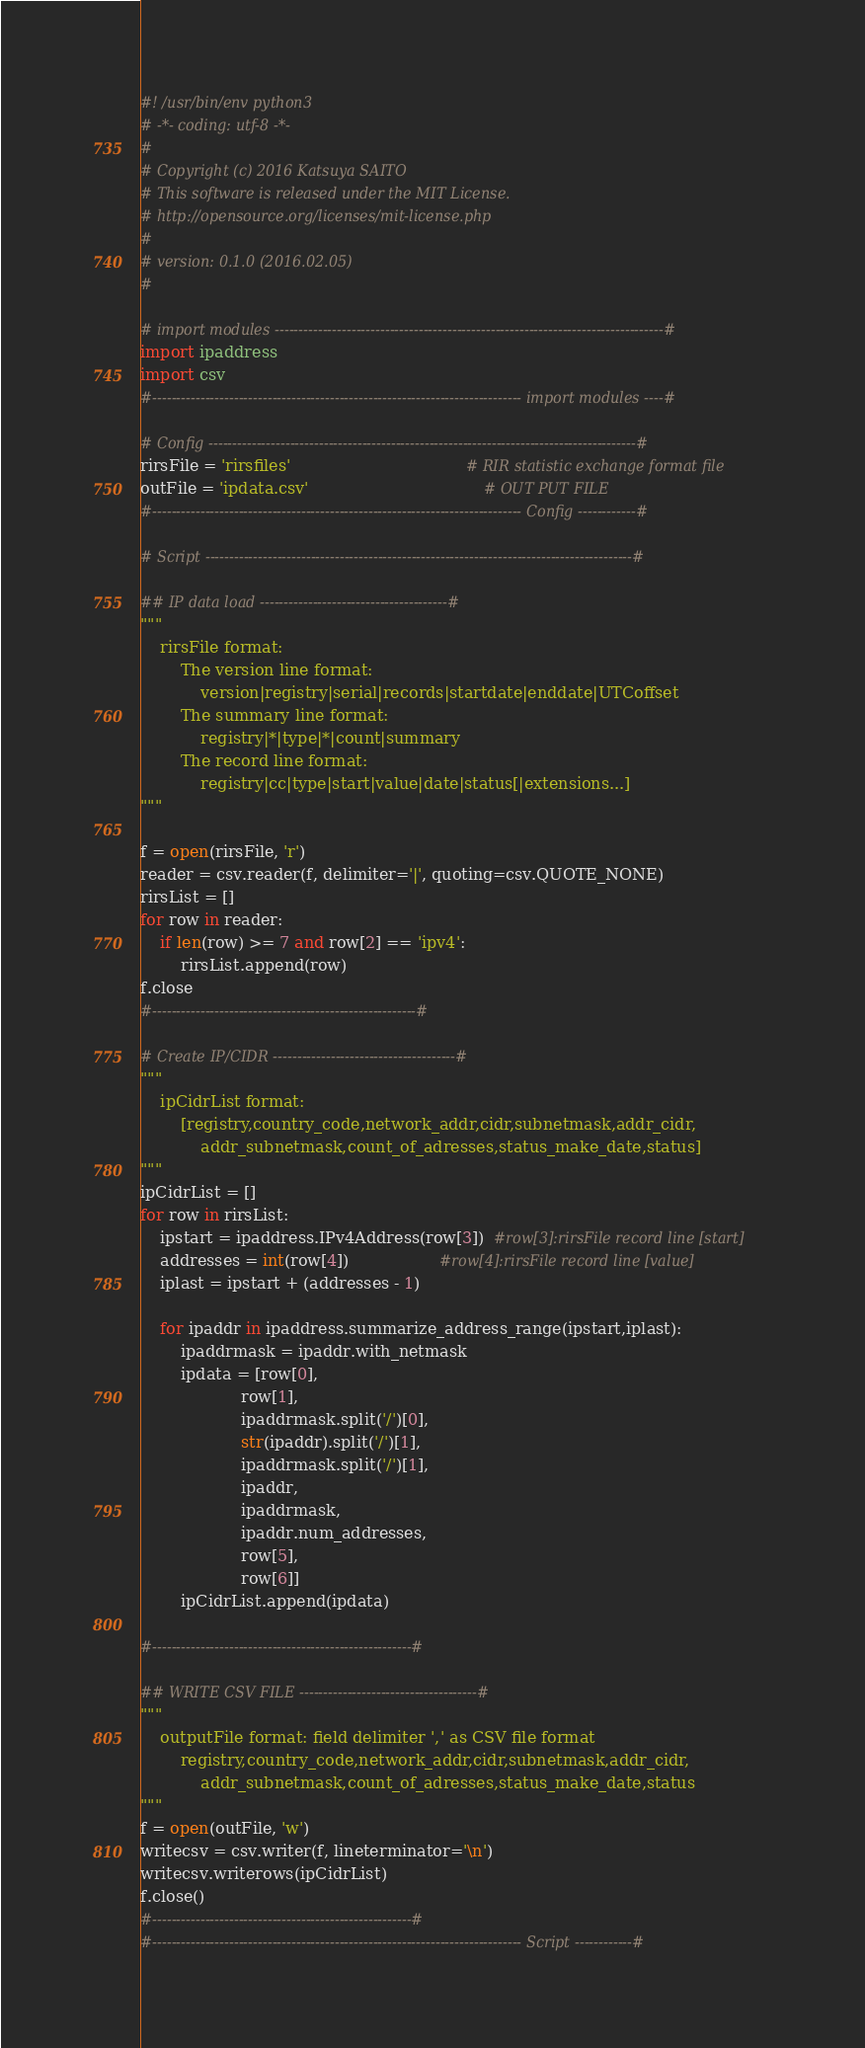<code> <loc_0><loc_0><loc_500><loc_500><_Python_>#! /usr/bin/env python3
# -*- coding: utf-8 -*-
#
# Copyright (c) 2016 Katsuya SAITO
# This software is released under the MIT License.
# http://opensource.org/licenses/mit-license.php
#
# version: 0.1.0 (2016.02.05)
#

# import modules ---------------------------------------------------------------------------------#
import ipaddress
import csv
#----------------------------------------------------------------------------- import modules ----#

# Config -----------------------------------------------------------------------------------------#
rirsFile = 'rirsfiles'                                   # RIR statistic exchange format file
outFile = 'ipdata.csv'                                   # OUT PUT FILE
#----------------------------------------------------------------------------- Config ------------#

# Script -----------------------------------------------------------------------------------------#

## IP data load ---------------------------------------#
"""
    rirsFile format:
        The version line format:
            version|registry|serial|records|startdate|enddate|UTCoffset
        The summary line format:
            registry|*|type|*|count|summary
        The record line format:
            registry|cc|type|start|value|date|status[|extensions...]
"""

f = open(rirsFile, 'r')
reader = csv.reader(f, delimiter='|', quoting=csv.QUOTE_NONE)
rirsList = []
for row in reader:
    if len(row) >= 7 and row[2] == 'ipv4':
        rirsList.append(row)
f.close
#-------------------------------------------------------#

# Create IP/CIDR --------------------------------------#
"""
    ipCidrList format:
        [registry,country_code,network_addr,cidr,subnetmask,addr_cidr,
            addr_subnetmask,count_of_adresses,status_make_date,status]
"""
ipCidrList = []
for row in rirsList:
    ipstart = ipaddress.IPv4Address(row[3])  #row[3]:rirsFile record line [start]
    addresses = int(row[4])                  #row[4]:rirsFile record line [value]
    iplast = ipstart + (addresses - 1)

    for ipaddr in ipaddress.summarize_address_range(ipstart,iplast):
        ipaddrmask = ipaddr.with_netmask
        ipdata = [row[0],
                    row[1],
                    ipaddrmask.split('/')[0],
                    str(ipaddr).split('/')[1],
                    ipaddrmask.split('/')[1],
                    ipaddr,
                    ipaddrmask,
                    ipaddr.num_addresses,
                    row[5],
                    row[6]]
        ipCidrList.append(ipdata)

#------------------------------------------------------#

## WRITE CSV FILE -------------------------------------#
"""
    outputFile format: field delimiter ',' as CSV file format
        registry,country_code,network_addr,cidr,subnetmask,addr_cidr,
            addr_subnetmask,count_of_adresses,status_make_date,status
"""
f = open(outFile, 'w')
writecsv = csv.writer(f, lineterminator='\n')
writecsv.writerows(ipCidrList)
f.close()
#------------------------------------------------------#
#----------------------------------------------------------------------------- Script ------------#
</code> 